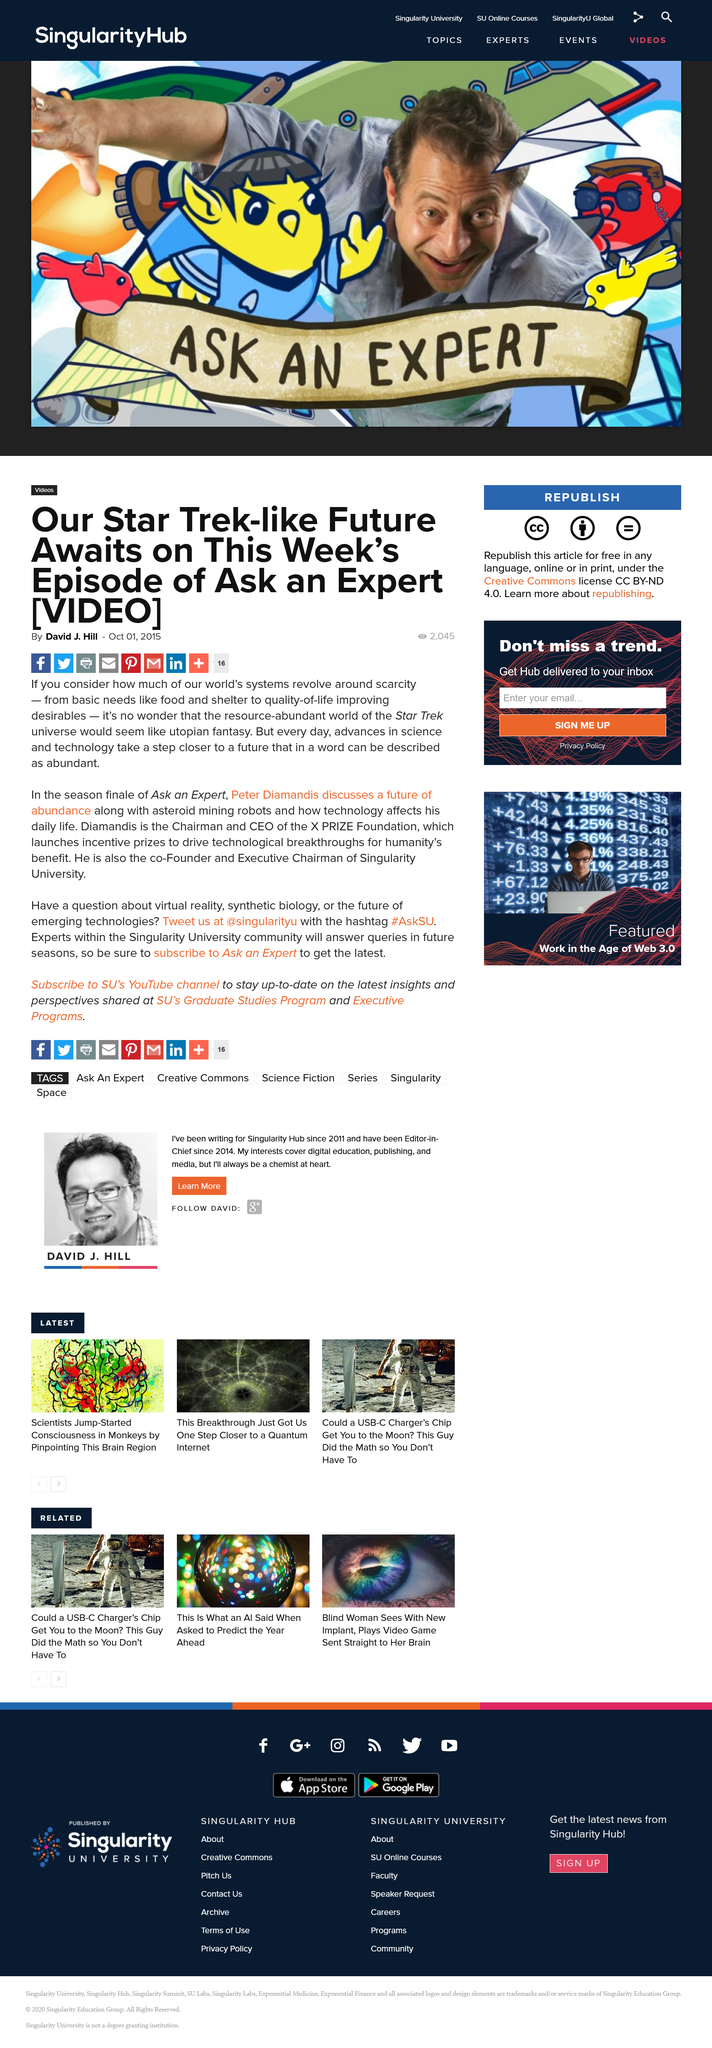Point out several critical features in this image. Singularity University has a YouTube channel. The author of this article is David J. Hill. The Twitter handle of Singularity University is @singularityu. 